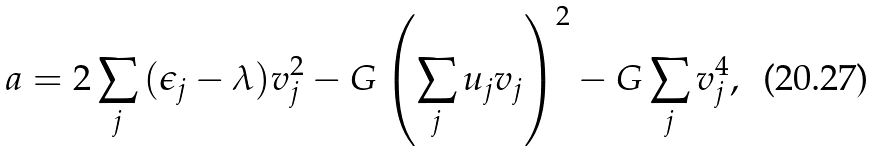Convert formula to latex. <formula><loc_0><loc_0><loc_500><loc_500>a = 2 \sum _ { j } { ( \epsilon _ { j } - \lambda ) v _ { j } ^ { 2 } } - G \left ( \sum _ { j } { u _ { j } v _ { j } } \right ) ^ { 2 } - G \sum _ { j } { v _ { j } ^ { 4 } } ,</formula> 